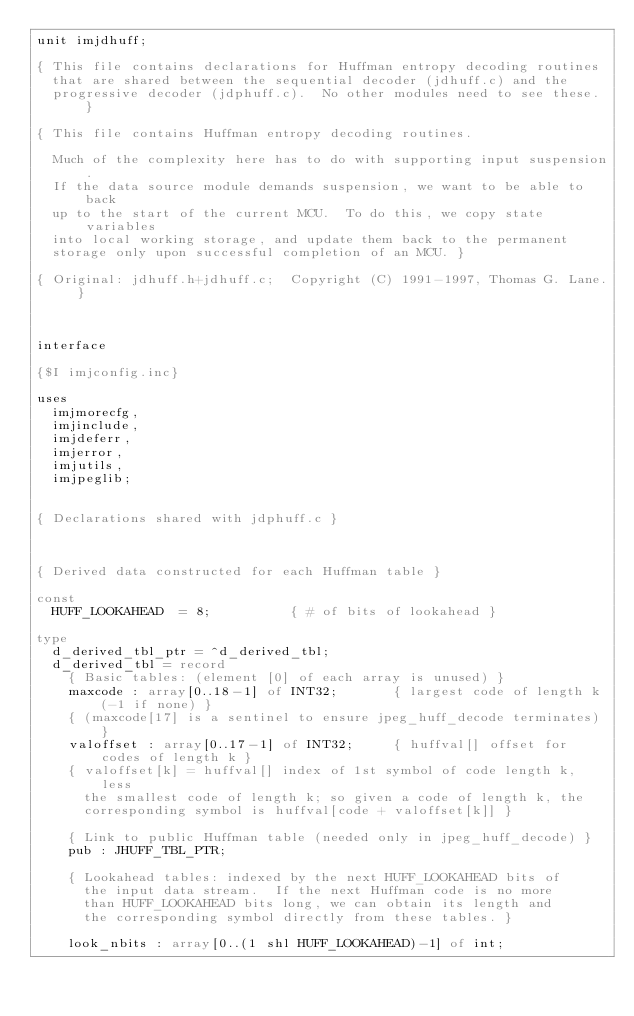<code> <loc_0><loc_0><loc_500><loc_500><_Pascal_>unit imjdhuff;

{ This file contains declarations for Huffman entropy decoding routines
  that are shared between the sequential decoder (jdhuff.c) and the
  progressive decoder (jdphuff.c).  No other modules need to see these. }

{ This file contains Huffman entropy decoding routines.

  Much of the complexity here has to do with supporting input suspension.
  If the data source module demands suspension, we want to be able to back
  up to the start of the current MCU.  To do this, we copy state variables
  into local working storage, and update them back to the permanent
  storage only upon successful completion of an MCU. }

{ Original: jdhuff.h+jdhuff.c;  Copyright (C) 1991-1997, Thomas G. Lane. }



interface

{$I imjconfig.inc}

uses
  imjmorecfg,
  imjinclude,
  imjdeferr,
  imjerror,
  imjutils,
  imjpeglib;


{ Declarations shared with jdphuff.c }



{ Derived data constructed for each Huffman table }

const
  HUFF_LOOKAHEAD  = 8;          { # of bits of lookahead }

type
  d_derived_tbl_ptr = ^d_derived_tbl;
  d_derived_tbl = record
    { Basic tables: (element [0] of each array is unused) }
    maxcode : array[0..18-1] of INT32;       { largest code of length k (-1 if none) }
    { (maxcode[17] is a sentinel to ensure jpeg_huff_decode terminates) }
    valoffset : array[0..17-1] of INT32;     { huffval[] offset for codes of length k }
    { valoffset[k] = huffval[] index of 1st symbol of code length k, less
      the smallest code of length k; so given a code of length k, the
      corresponding symbol is huffval[code + valoffset[k]] }

    { Link to public Huffman table (needed only in jpeg_huff_decode) }
    pub : JHUFF_TBL_PTR;

    { Lookahead tables: indexed by the next HUFF_LOOKAHEAD bits of
      the input data stream.  If the next Huffman code is no more
      than HUFF_LOOKAHEAD bits long, we can obtain its length and
      the corresponding symbol directly from these tables. }

    look_nbits : array[0..(1 shl HUFF_LOOKAHEAD)-1] of int;</code> 